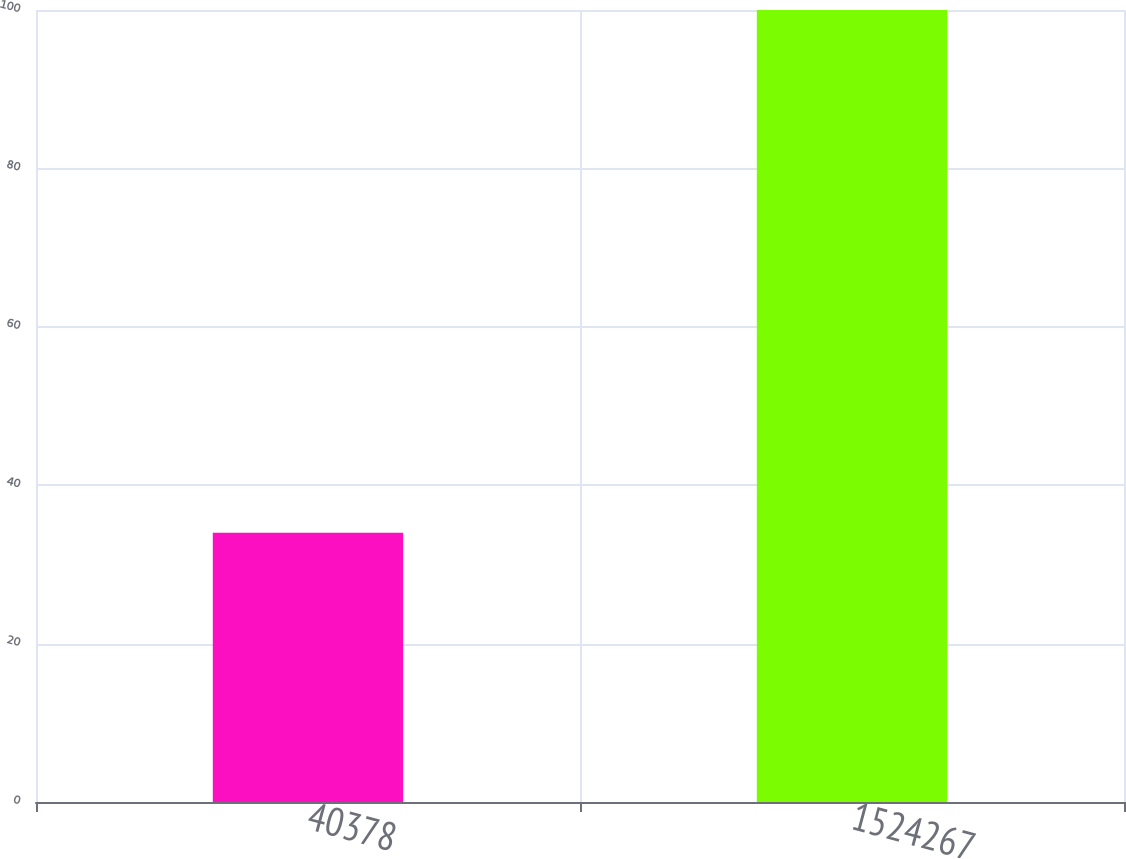Convert chart to OTSL. <chart><loc_0><loc_0><loc_500><loc_500><bar_chart><fcel>40378<fcel>1524267<nl><fcel>34<fcel>100<nl></chart> 